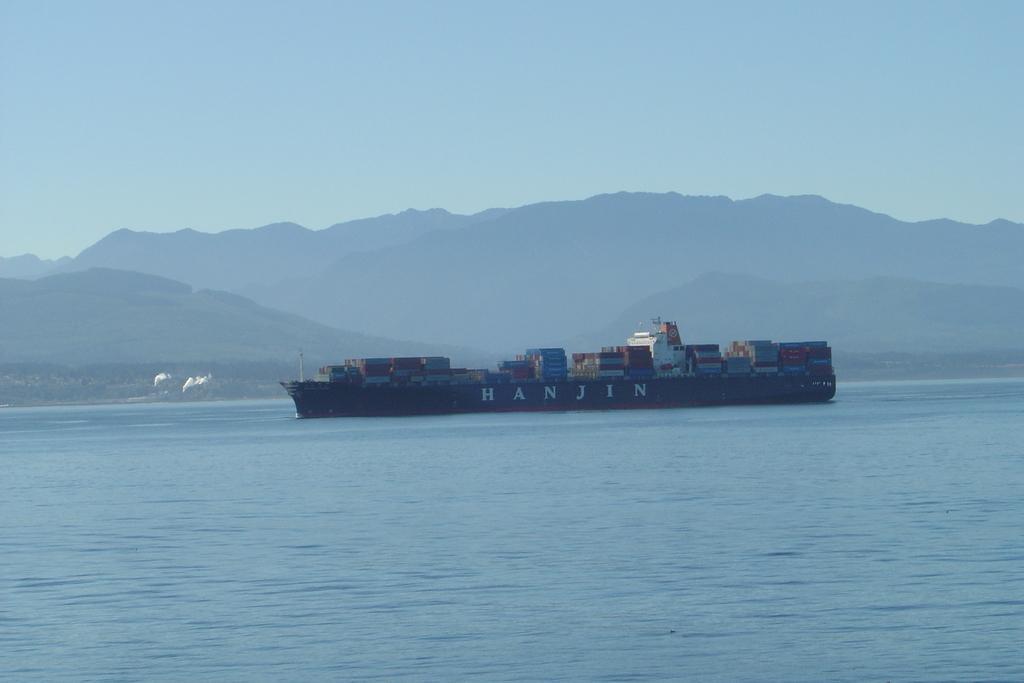Please provide a concise description of this image. In this image I can see water and on it I can see a ship. I can also see number of cargo containers on the ship and I can see something is written on the ship. In the background I can see mountains and the sky. 